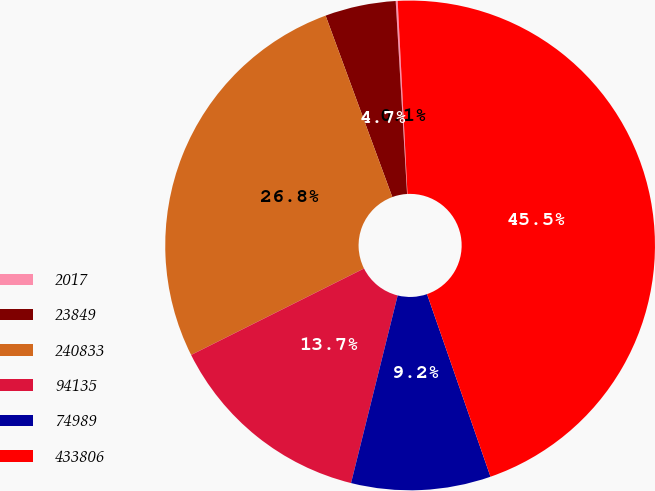Convert chart to OTSL. <chart><loc_0><loc_0><loc_500><loc_500><pie_chart><fcel>2017<fcel>23849<fcel>240833<fcel>94135<fcel>74989<fcel>433806<nl><fcel>0.13%<fcel>4.67%<fcel>26.77%<fcel>13.74%<fcel>9.2%<fcel>45.48%<nl></chart> 